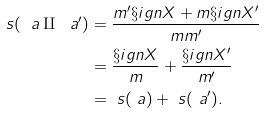Convert formula to latex. <formula><loc_0><loc_0><loc_500><loc_500>\ s ( \ a \amalg \ a ^ { \prime } ) & = \frac { m ^ { \prime } \S i g n X + m \S i g n X ^ { \prime } } { m m ^ { \prime } } \\ & = \frac { \S i g n X } { m } + \frac { \S i g n X ^ { \prime } } { m ^ { \prime } } \\ & = \ s ( \ a ) + \ s ( \ a ^ { \prime } ) .</formula> 